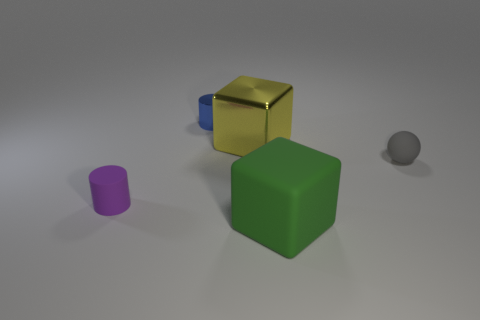Add 4 big purple cubes. How many objects exist? 9 Subtract all green blocks. How many blocks are left? 1 Subtract 1 cubes. How many cubes are left? 1 Add 5 tiny gray objects. How many tiny gray objects exist? 6 Subtract 0 red spheres. How many objects are left? 5 Subtract all blocks. How many objects are left? 3 Subtract all cyan cylinders. Subtract all gray spheres. How many cylinders are left? 2 Subtract all red spheres. How many blue cylinders are left? 1 Subtract all big cubes. Subtract all metallic cylinders. How many objects are left? 2 Add 1 purple matte objects. How many purple matte objects are left? 2 